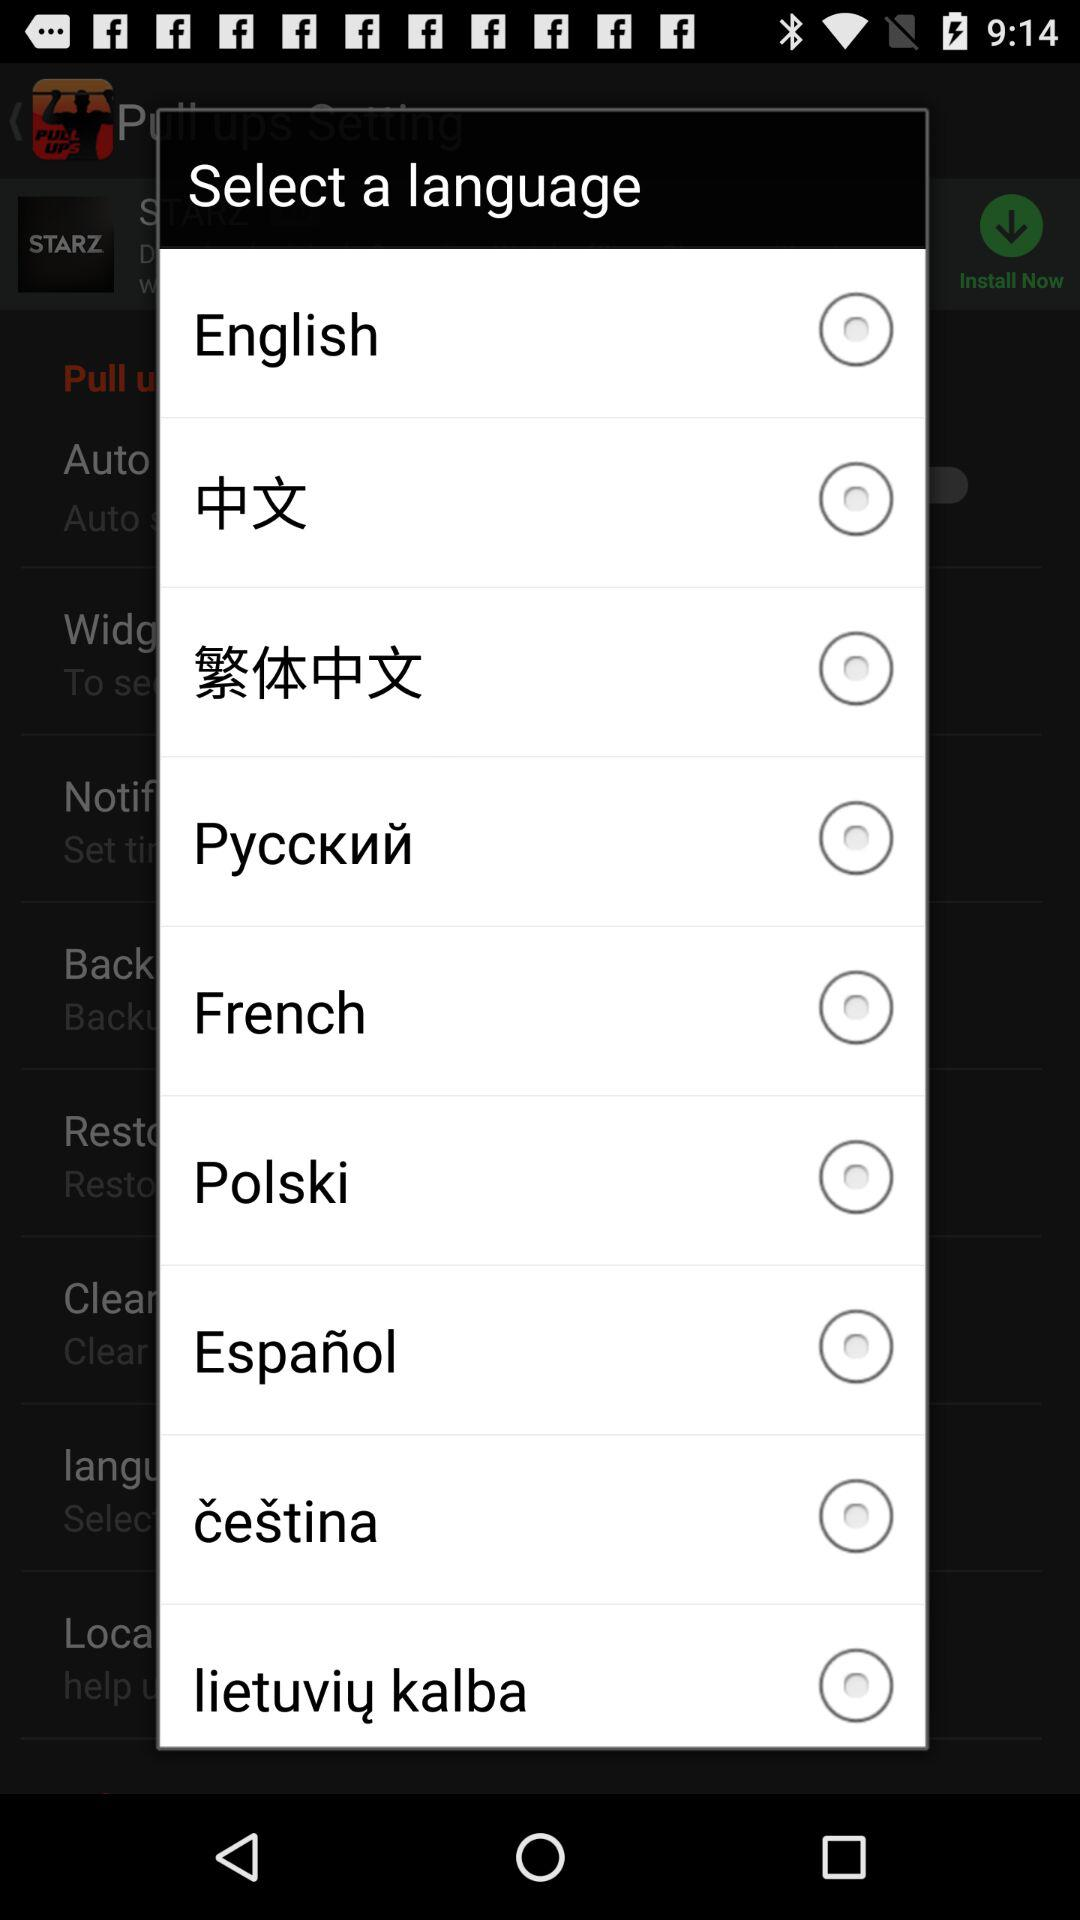What is the status of "Polski"? The status is "off". 